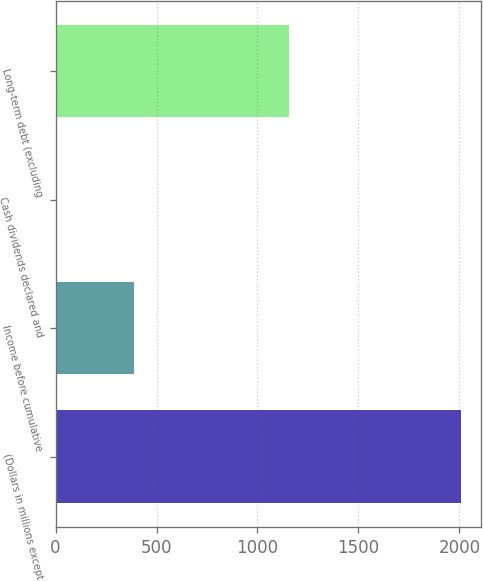Convert chart to OTSL. <chart><loc_0><loc_0><loc_500><loc_500><bar_chart><fcel>(Dollars in millions except<fcel>Income before cumulative<fcel>Cash dividends declared and<fcel>Long-term debt (excluding<nl><fcel>2006<fcel>386.76<fcel>1.84<fcel>1156.6<nl></chart> 